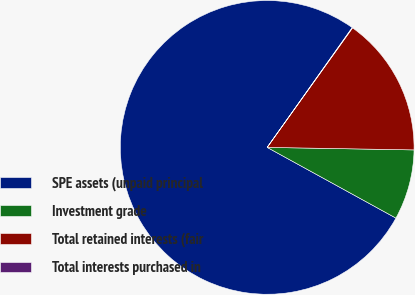Convert chart. <chart><loc_0><loc_0><loc_500><loc_500><pie_chart><fcel>SPE assets (unpaid principal<fcel>Investment grade<fcel>Total retained interests (fair<fcel>Total interests purchased in<nl><fcel>76.83%<fcel>7.72%<fcel>15.4%<fcel>0.05%<nl></chart> 